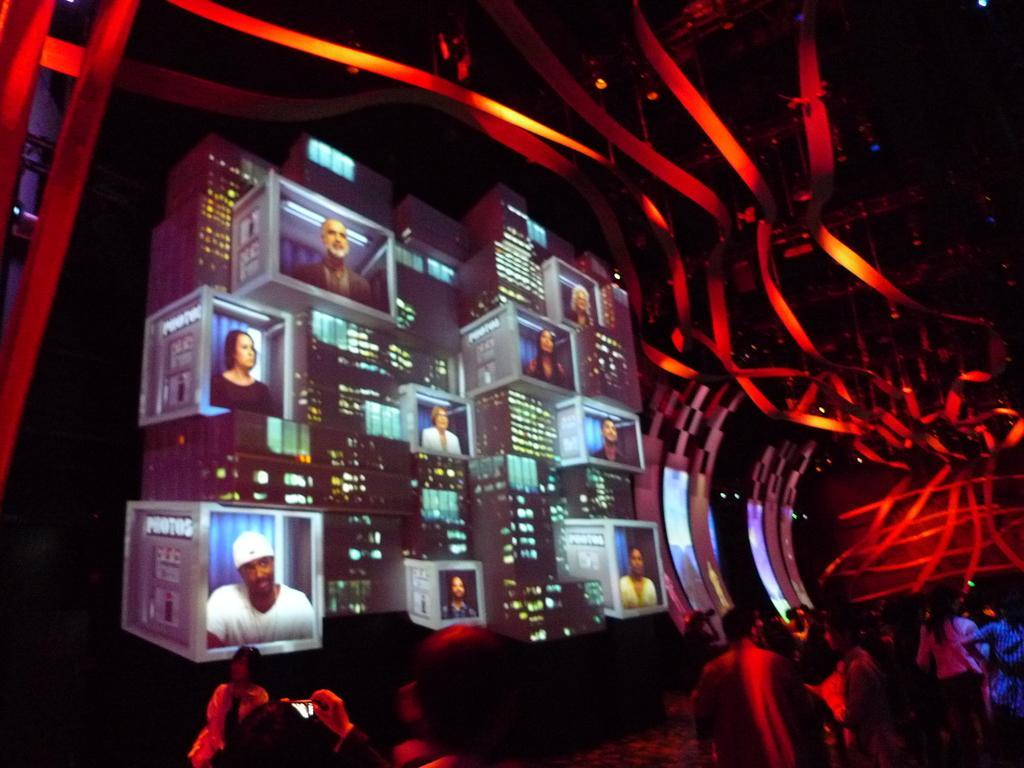Could you give a brief overview of what you see in this image? At the bottom of the image there are many people. Also there are screens with images of different people. Also there are red color lights. 